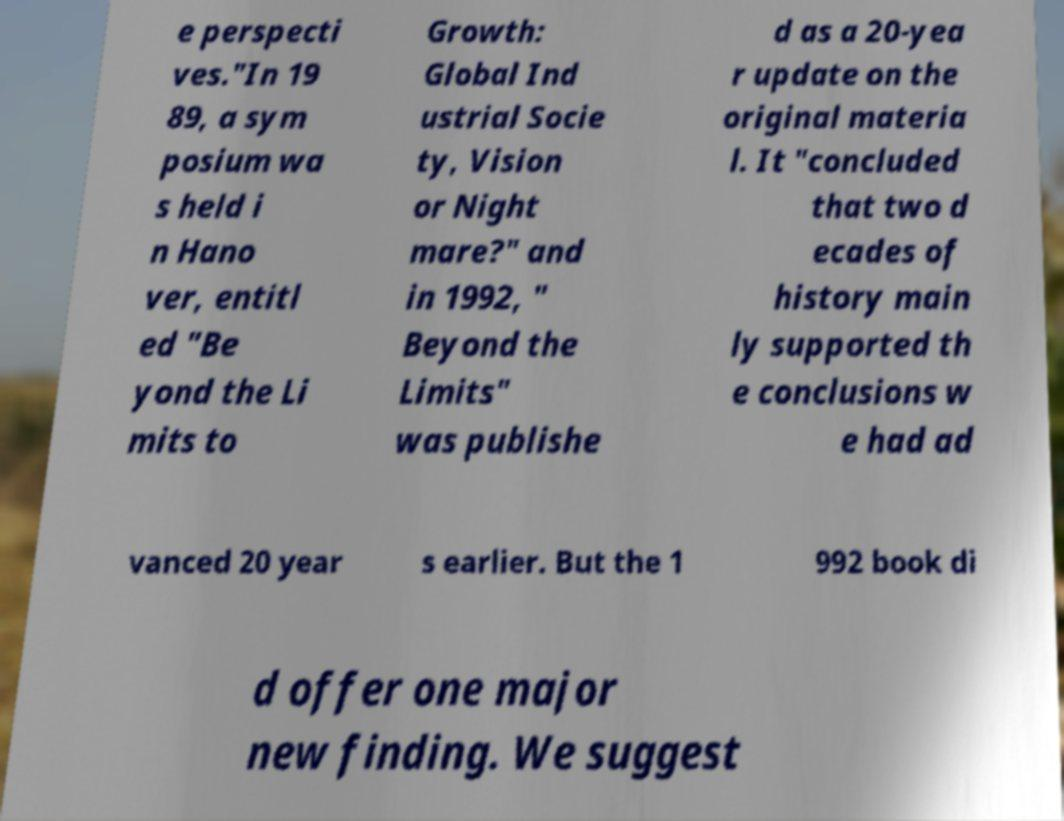Can you accurately transcribe the text from the provided image for me? e perspecti ves."In 19 89, a sym posium wa s held i n Hano ver, entitl ed "Be yond the Li mits to Growth: Global Ind ustrial Socie ty, Vision or Night mare?" and in 1992, " Beyond the Limits" was publishe d as a 20-yea r update on the original materia l. It "concluded that two d ecades of history main ly supported th e conclusions w e had ad vanced 20 year s earlier. But the 1 992 book di d offer one major new finding. We suggest 